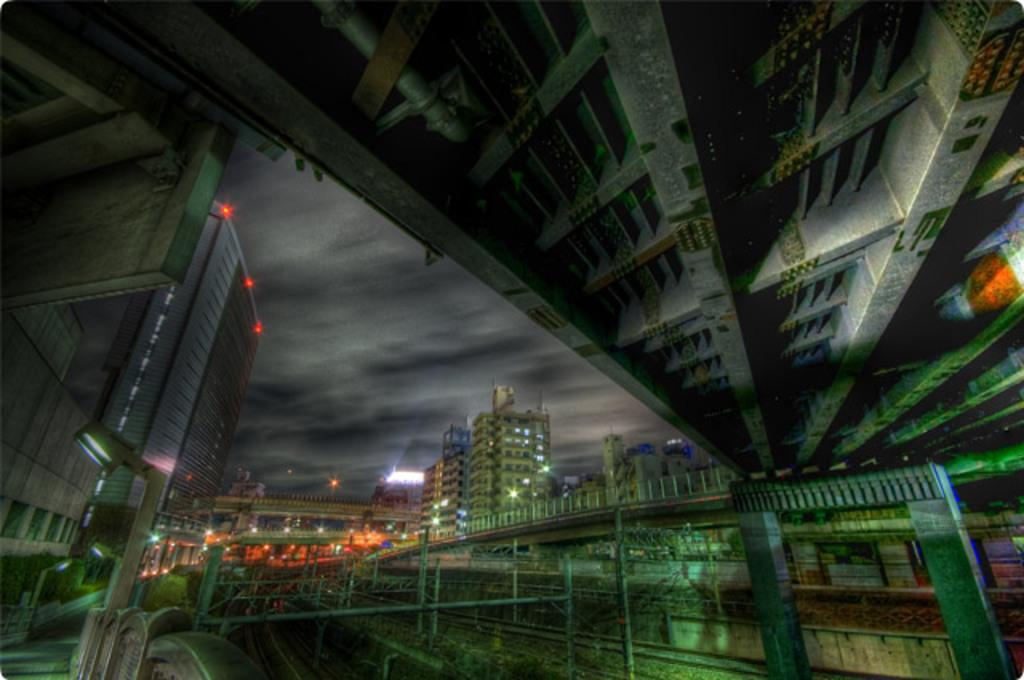What type of structures can be seen in the image? There are buildings in the image. Is there any connection between the buildings? Yes, there is a bridge between the buildings in the image. What is visible at the top of the image? The sky is visible at the top of the image. What might be the purpose of the ceiling in the image? The ceiling could provide shelter or protection from the elements. Where is the dock located in the image? There is no dock present in the image. What direction is the floor facing in the image? There is no floor present in the image, so it is not possible to determine the direction it might be facing. 